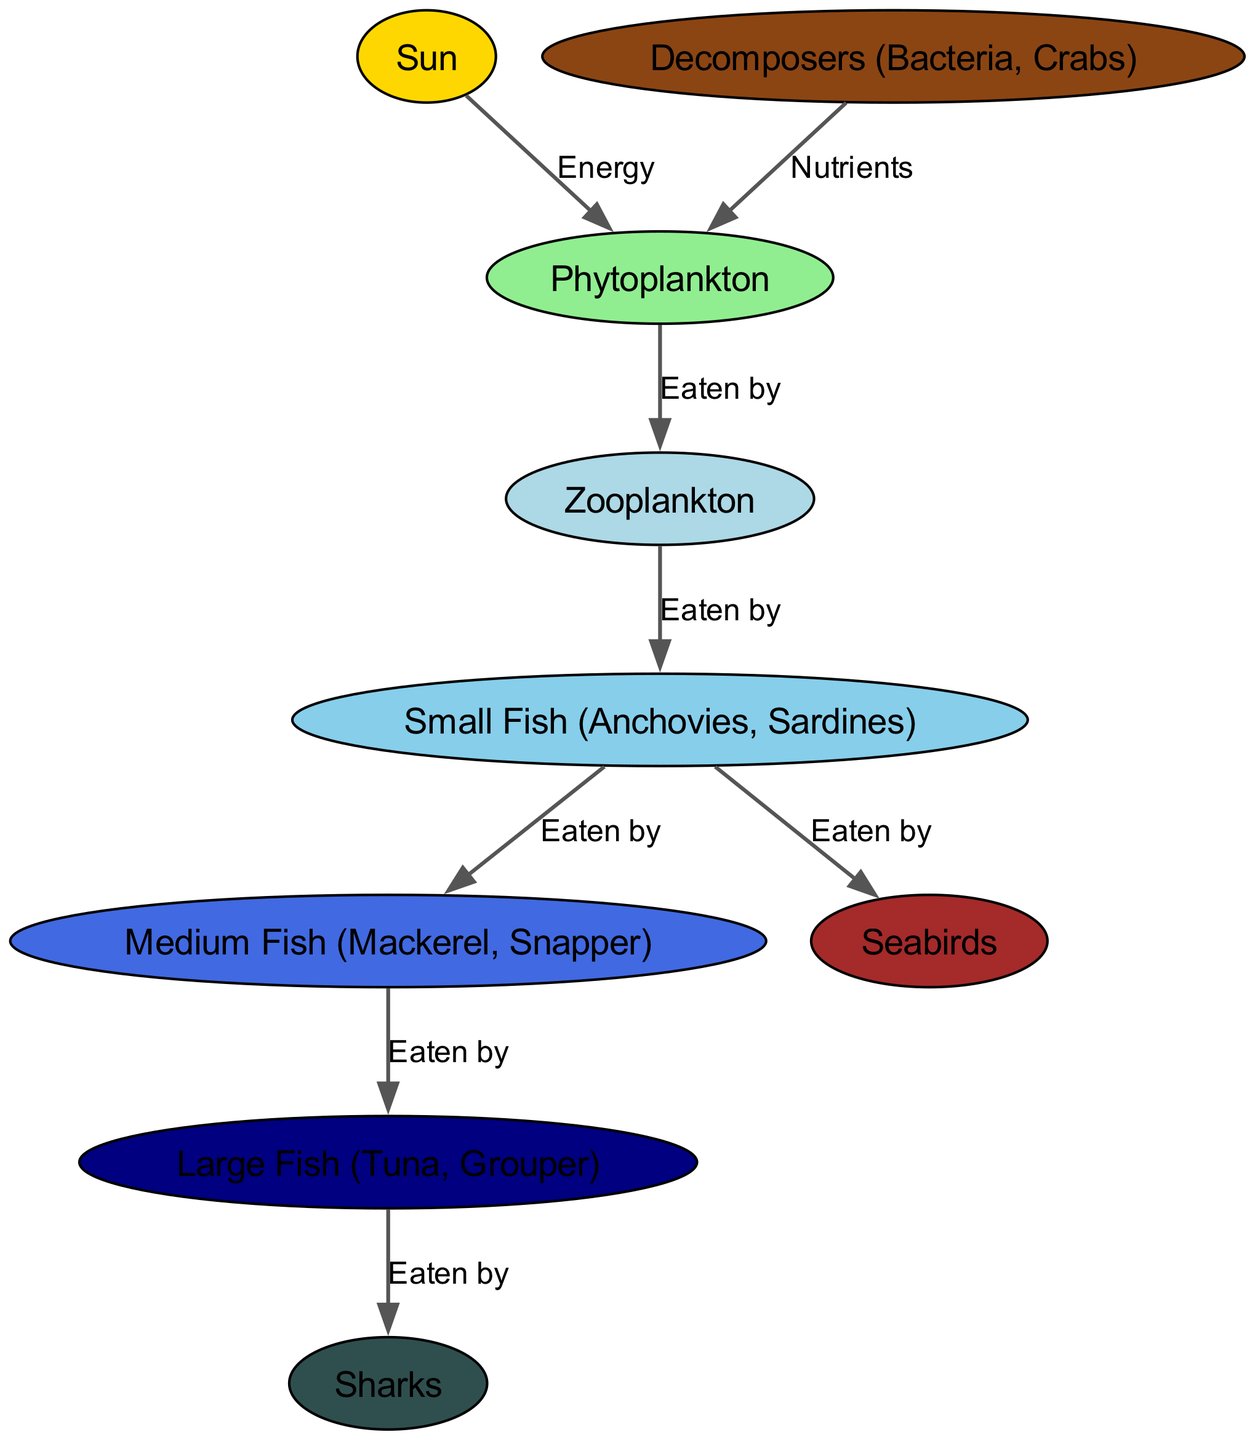What is the starting point of the food web? The food web begins with the sun, which is the primary source of energy for all organisms in this ecosystem.
Answer: Sun How many species are in the diagram? There are nine species represented in the diagram. These include the sun, phytoplankton, zooplankton, small fish, medium fish, large fish, sharks, seabirds, and decomposers.
Answer: Nine Which organism is eaten by the medium fish? The medium fish eat small fish, according to the connections illustrated in the diagram.
Answer: Small Fish What do decomposers provide to phytoplankton? Decomposers, such as bacteria and crabs, provide nutrients, which are essential for the growth of phytoplankton.
Answer: Nutrients Which species feeds at the highest level in the food web? Sharks are depicted as the apex predators in the food web, meaning they are at the highest level and have no natural predators.
Answer: Sharks How many types of fish are shown in the diagram? The diagram displays three types of fish: small fish, medium fish, and large fish.
Answer: Three Which organisms do zooplankton feed on? Zooplankton primarily feed on phytoplankton, highlighting their role as primary consumers in the marine ecosystem.
Answer: Phytoplankton What is the relationship between large fish and sharks? Large fish are a food source for sharks, indicating a predatory relationship within the food web.
Answer: Eaten by Which organism connects the sun to the zooplankton? Phytoplankton serve as a critical link between the sun, absorbing its energy, and zooplankton, which feed on them.
Answer: Phytoplankton 